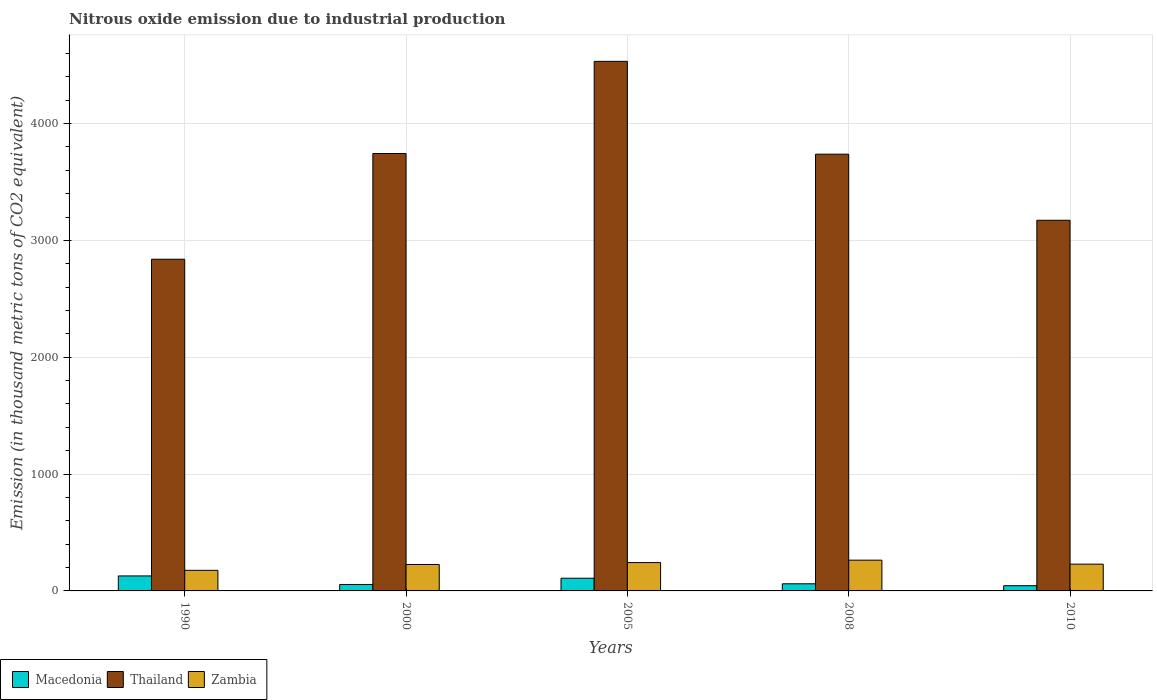How many different coloured bars are there?
Your response must be concise. 3. How many groups of bars are there?
Your answer should be very brief. 5. Are the number of bars per tick equal to the number of legend labels?
Your answer should be very brief. Yes. Are the number of bars on each tick of the X-axis equal?
Provide a succinct answer. Yes. How many bars are there on the 3rd tick from the left?
Ensure brevity in your answer.  3. What is the label of the 2nd group of bars from the left?
Provide a succinct answer. 2000. In how many cases, is the number of bars for a given year not equal to the number of legend labels?
Give a very brief answer. 0. What is the amount of nitrous oxide emitted in Macedonia in 1990?
Your answer should be very brief. 128.3. Across all years, what is the maximum amount of nitrous oxide emitted in Thailand?
Make the answer very short. 4532.4. Across all years, what is the minimum amount of nitrous oxide emitted in Zambia?
Your response must be concise. 176.2. In which year was the amount of nitrous oxide emitted in Thailand minimum?
Offer a terse response. 1990. What is the total amount of nitrous oxide emitted in Zambia in the graph?
Keep it short and to the point. 1137.6. What is the difference between the amount of nitrous oxide emitted in Zambia in 2005 and the amount of nitrous oxide emitted in Thailand in 1990?
Your answer should be very brief. -2596.2. What is the average amount of nitrous oxide emitted in Macedonia per year?
Offer a very short reply. 79.54. In the year 2010, what is the difference between the amount of nitrous oxide emitted in Zambia and amount of nitrous oxide emitted in Thailand?
Keep it short and to the point. -2943.2. What is the ratio of the amount of nitrous oxide emitted in Zambia in 2000 to that in 2005?
Provide a succinct answer. 0.93. Is the difference between the amount of nitrous oxide emitted in Zambia in 1990 and 2005 greater than the difference between the amount of nitrous oxide emitted in Thailand in 1990 and 2005?
Offer a very short reply. Yes. What is the difference between the highest and the second highest amount of nitrous oxide emitted in Thailand?
Your answer should be very brief. 788.7. What is the difference between the highest and the lowest amount of nitrous oxide emitted in Zambia?
Provide a succinct answer. 87.1. What does the 2nd bar from the left in 2005 represents?
Keep it short and to the point. Thailand. What does the 1st bar from the right in 2008 represents?
Keep it short and to the point. Zambia. Is it the case that in every year, the sum of the amount of nitrous oxide emitted in Thailand and amount of nitrous oxide emitted in Macedonia is greater than the amount of nitrous oxide emitted in Zambia?
Keep it short and to the point. Yes. How many bars are there?
Offer a very short reply. 15. Are all the bars in the graph horizontal?
Your answer should be very brief. No. How many years are there in the graph?
Make the answer very short. 5. What is the difference between two consecutive major ticks on the Y-axis?
Keep it short and to the point. 1000. Where does the legend appear in the graph?
Provide a succinct answer. Bottom left. How are the legend labels stacked?
Provide a succinct answer. Horizontal. What is the title of the graph?
Ensure brevity in your answer.  Nitrous oxide emission due to industrial production. What is the label or title of the X-axis?
Provide a succinct answer. Years. What is the label or title of the Y-axis?
Your response must be concise. Emission (in thousand metric tons of CO2 equivalent). What is the Emission (in thousand metric tons of CO2 equivalent) in Macedonia in 1990?
Your answer should be very brief. 128.3. What is the Emission (in thousand metric tons of CO2 equivalent) of Thailand in 1990?
Make the answer very short. 2838.9. What is the Emission (in thousand metric tons of CO2 equivalent) of Zambia in 1990?
Offer a very short reply. 176.2. What is the Emission (in thousand metric tons of CO2 equivalent) in Macedonia in 2000?
Make the answer very short. 55.2. What is the Emission (in thousand metric tons of CO2 equivalent) of Thailand in 2000?
Give a very brief answer. 3743.7. What is the Emission (in thousand metric tons of CO2 equivalent) of Zambia in 2000?
Give a very brief answer. 226.2. What is the Emission (in thousand metric tons of CO2 equivalent) of Macedonia in 2005?
Make the answer very short. 108.6. What is the Emission (in thousand metric tons of CO2 equivalent) of Thailand in 2005?
Make the answer very short. 4532.4. What is the Emission (in thousand metric tons of CO2 equivalent) in Zambia in 2005?
Your response must be concise. 242.7. What is the Emission (in thousand metric tons of CO2 equivalent) of Macedonia in 2008?
Provide a short and direct response. 61. What is the Emission (in thousand metric tons of CO2 equivalent) in Thailand in 2008?
Provide a succinct answer. 3737.9. What is the Emission (in thousand metric tons of CO2 equivalent) in Zambia in 2008?
Your response must be concise. 263.3. What is the Emission (in thousand metric tons of CO2 equivalent) of Macedonia in 2010?
Give a very brief answer. 44.6. What is the Emission (in thousand metric tons of CO2 equivalent) in Thailand in 2010?
Your answer should be very brief. 3172.4. What is the Emission (in thousand metric tons of CO2 equivalent) of Zambia in 2010?
Make the answer very short. 229.2. Across all years, what is the maximum Emission (in thousand metric tons of CO2 equivalent) of Macedonia?
Your answer should be very brief. 128.3. Across all years, what is the maximum Emission (in thousand metric tons of CO2 equivalent) of Thailand?
Provide a succinct answer. 4532.4. Across all years, what is the maximum Emission (in thousand metric tons of CO2 equivalent) in Zambia?
Provide a short and direct response. 263.3. Across all years, what is the minimum Emission (in thousand metric tons of CO2 equivalent) in Macedonia?
Ensure brevity in your answer.  44.6. Across all years, what is the minimum Emission (in thousand metric tons of CO2 equivalent) of Thailand?
Give a very brief answer. 2838.9. Across all years, what is the minimum Emission (in thousand metric tons of CO2 equivalent) in Zambia?
Your answer should be very brief. 176.2. What is the total Emission (in thousand metric tons of CO2 equivalent) in Macedonia in the graph?
Offer a very short reply. 397.7. What is the total Emission (in thousand metric tons of CO2 equivalent) of Thailand in the graph?
Offer a terse response. 1.80e+04. What is the total Emission (in thousand metric tons of CO2 equivalent) in Zambia in the graph?
Provide a short and direct response. 1137.6. What is the difference between the Emission (in thousand metric tons of CO2 equivalent) of Macedonia in 1990 and that in 2000?
Give a very brief answer. 73.1. What is the difference between the Emission (in thousand metric tons of CO2 equivalent) in Thailand in 1990 and that in 2000?
Ensure brevity in your answer.  -904.8. What is the difference between the Emission (in thousand metric tons of CO2 equivalent) in Macedonia in 1990 and that in 2005?
Provide a succinct answer. 19.7. What is the difference between the Emission (in thousand metric tons of CO2 equivalent) of Thailand in 1990 and that in 2005?
Give a very brief answer. -1693.5. What is the difference between the Emission (in thousand metric tons of CO2 equivalent) in Zambia in 1990 and that in 2005?
Give a very brief answer. -66.5. What is the difference between the Emission (in thousand metric tons of CO2 equivalent) in Macedonia in 1990 and that in 2008?
Your response must be concise. 67.3. What is the difference between the Emission (in thousand metric tons of CO2 equivalent) of Thailand in 1990 and that in 2008?
Provide a succinct answer. -899. What is the difference between the Emission (in thousand metric tons of CO2 equivalent) in Zambia in 1990 and that in 2008?
Provide a short and direct response. -87.1. What is the difference between the Emission (in thousand metric tons of CO2 equivalent) in Macedonia in 1990 and that in 2010?
Give a very brief answer. 83.7. What is the difference between the Emission (in thousand metric tons of CO2 equivalent) in Thailand in 1990 and that in 2010?
Provide a succinct answer. -333.5. What is the difference between the Emission (in thousand metric tons of CO2 equivalent) in Zambia in 1990 and that in 2010?
Your answer should be very brief. -53. What is the difference between the Emission (in thousand metric tons of CO2 equivalent) in Macedonia in 2000 and that in 2005?
Your answer should be very brief. -53.4. What is the difference between the Emission (in thousand metric tons of CO2 equivalent) in Thailand in 2000 and that in 2005?
Offer a very short reply. -788.7. What is the difference between the Emission (in thousand metric tons of CO2 equivalent) in Zambia in 2000 and that in 2005?
Your answer should be very brief. -16.5. What is the difference between the Emission (in thousand metric tons of CO2 equivalent) in Macedonia in 2000 and that in 2008?
Give a very brief answer. -5.8. What is the difference between the Emission (in thousand metric tons of CO2 equivalent) of Zambia in 2000 and that in 2008?
Your answer should be compact. -37.1. What is the difference between the Emission (in thousand metric tons of CO2 equivalent) of Macedonia in 2000 and that in 2010?
Make the answer very short. 10.6. What is the difference between the Emission (in thousand metric tons of CO2 equivalent) in Thailand in 2000 and that in 2010?
Provide a short and direct response. 571.3. What is the difference between the Emission (in thousand metric tons of CO2 equivalent) in Zambia in 2000 and that in 2010?
Offer a very short reply. -3. What is the difference between the Emission (in thousand metric tons of CO2 equivalent) of Macedonia in 2005 and that in 2008?
Give a very brief answer. 47.6. What is the difference between the Emission (in thousand metric tons of CO2 equivalent) in Thailand in 2005 and that in 2008?
Give a very brief answer. 794.5. What is the difference between the Emission (in thousand metric tons of CO2 equivalent) of Zambia in 2005 and that in 2008?
Your response must be concise. -20.6. What is the difference between the Emission (in thousand metric tons of CO2 equivalent) in Macedonia in 2005 and that in 2010?
Offer a very short reply. 64. What is the difference between the Emission (in thousand metric tons of CO2 equivalent) in Thailand in 2005 and that in 2010?
Provide a succinct answer. 1360. What is the difference between the Emission (in thousand metric tons of CO2 equivalent) in Zambia in 2005 and that in 2010?
Offer a terse response. 13.5. What is the difference between the Emission (in thousand metric tons of CO2 equivalent) of Thailand in 2008 and that in 2010?
Give a very brief answer. 565.5. What is the difference between the Emission (in thousand metric tons of CO2 equivalent) in Zambia in 2008 and that in 2010?
Give a very brief answer. 34.1. What is the difference between the Emission (in thousand metric tons of CO2 equivalent) of Macedonia in 1990 and the Emission (in thousand metric tons of CO2 equivalent) of Thailand in 2000?
Provide a short and direct response. -3615.4. What is the difference between the Emission (in thousand metric tons of CO2 equivalent) of Macedonia in 1990 and the Emission (in thousand metric tons of CO2 equivalent) of Zambia in 2000?
Keep it short and to the point. -97.9. What is the difference between the Emission (in thousand metric tons of CO2 equivalent) in Thailand in 1990 and the Emission (in thousand metric tons of CO2 equivalent) in Zambia in 2000?
Your answer should be compact. 2612.7. What is the difference between the Emission (in thousand metric tons of CO2 equivalent) of Macedonia in 1990 and the Emission (in thousand metric tons of CO2 equivalent) of Thailand in 2005?
Provide a short and direct response. -4404.1. What is the difference between the Emission (in thousand metric tons of CO2 equivalent) in Macedonia in 1990 and the Emission (in thousand metric tons of CO2 equivalent) in Zambia in 2005?
Ensure brevity in your answer.  -114.4. What is the difference between the Emission (in thousand metric tons of CO2 equivalent) in Thailand in 1990 and the Emission (in thousand metric tons of CO2 equivalent) in Zambia in 2005?
Your answer should be compact. 2596.2. What is the difference between the Emission (in thousand metric tons of CO2 equivalent) in Macedonia in 1990 and the Emission (in thousand metric tons of CO2 equivalent) in Thailand in 2008?
Offer a terse response. -3609.6. What is the difference between the Emission (in thousand metric tons of CO2 equivalent) of Macedonia in 1990 and the Emission (in thousand metric tons of CO2 equivalent) of Zambia in 2008?
Your response must be concise. -135. What is the difference between the Emission (in thousand metric tons of CO2 equivalent) in Thailand in 1990 and the Emission (in thousand metric tons of CO2 equivalent) in Zambia in 2008?
Your answer should be very brief. 2575.6. What is the difference between the Emission (in thousand metric tons of CO2 equivalent) in Macedonia in 1990 and the Emission (in thousand metric tons of CO2 equivalent) in Thailand in 2010?
Give a very brief answer. -3044.1. What is the difference between the Emission (in thousand metric tons of CO2 equivalent) in Macedonia in 1990 and the Emission (in thousand metric tons of CO2 equivalent) in Zambia in 2010?
Your response must be concise. -100.9. What is the difference between the Emission (in thousand metric tons of CO2 equivalent) in Thailand in 1990 and the Emission (in thousand metric tons of CO2 equivalent) in Zambia in 2010?
Keep it short and to the point. 2609.7. What is the difference between the Emission (in thousand metric tons of CO2 equivalent) of Macedonia in 2000 and the Emission (in thousand metric tons of CO2 equivalent) of Thailand in 2005?
Make the answer very short. -4477.2. What is the difference between the Emission (in thousand metric tons of CO2 equivalent) in Macedonia in 2000 and the Emission (in thousand metric tons of CO2 equivalent) in Zambia in 2005?
Your answer should be very brief. -187.5. What is the difference between the Emission (in thousand metric tons of CO2 equivalent) of Thailand in 2000 and the Emission (in thousand metric tons of CO2 equivalent) of Zambia in 2005?
Your answer should be very brief. 3501. What is the difference between the Emission (in thousand metric tons of CO2 equivalent) of Macedonia in 2000 and the Emission (in thousand metric tons of CO2 equivalent) of Thailand in 2008?
Make the answer very short. -3682.7. What is the difference between the Emission (in thousand metric tons of CO2 equivalent) of Macedonia in 2000 and the Emission (in thousand metric tons of CO2 equivalent) of Zambia in 2008?
Provide a short and direct response. -208.1. What is the difference between the Emission (in thousand metric tons of CO2 equivalent) of Thailand in 2000 and the Emission (in thousand metric tons of CO2 equivalent) of Zambia in 2008?
Give a very brief answer. 3480.4. What is the difference between the Emission (in thousand metric tons of CO2 equivalent) in Macedonia in 2000 and the Emission (in thousand metric tons of CO2 equivalent) in Thailand in 2010?
Ensure brevity in your answer.  -3117.2. What is the difference between the Emission (in thousand metric tons of CO2 equivalent) of Macedonia in 2000 and the Emission (in thousand metric tons of CO2 equivalent) of Zambia in 2010?
Provide a short and direct response. -174. What is the difference between the Emission (in thousand metric tons of CO2 equivalent) of Thailand in 2000 and the Emission (in thousand metric tons of CO2 equivalent) of Zambia in 2010?
Your answer should be very brief. 3514.5. What is the difference between the Emission (in thousand metric tons of CO2 equivalent) of Macedonia in 2005 and the Emission (in thousand metric tons of CO2 equivalent) of Thailand in 2008?
Ensure brevity in your answer.  -3629.3. What is the difference between the Emission (in thousand metric tons of CO2 equivalent) in Macedonia in 2005 and the Emission (in thousand metric tons of CO2 equivalent) in Zambia in 2008?
Keep it short and to the point. -154.7. What is the difference between the Emission (in thousand metric tons of CO2 equivalent) in Thailand in 2005 and the Emission (in thousand metric tons of CO2 equivalent) in Zambia in 2008?
Provide a short and direct response. 4269.1. What is the difference between the Emission (in thousand metric tons of CO2 equivalent) of Macedonia in 2005 and the Emission (in thousand metric tons of CO2 equivalent) of Thailand in 2010?
Offer a terse response. -3063.8. What is the difference between the Emission (in thousand metric tons of CO2 equivalent) in Macedonia in 2005 and the Emission (in thousand metric tons of CO2 equivalent) in Zambia in 2010?
Offer a terse response. -120.6. What is the difference between the Emission (in thousand metric tons of CO2 equivalent) in Thailand in 2005 and the Emission (in thousand metric tons of CO2 equivalent) in Zambia in 2010?
Provide a succinct answer. 4303.2. What is the difference between the Emission (in thousand metric tons of CO2 equivalent) of Macedonia in 2008 and the Emission (in thousand metric tons of CO2 equivalent) of Thailand in 2010?
Give a very brief answer. -3111.4. What is the difference between the Emission (in thousand metric tons of CO2 equivalent) in Macedonia in 2008 and the Emission (in thousand metric tons of CO2 equivalent) in Zambia in 2010?
Offer a very short reply. -168.2. What is the difference between the Emission (in thousand metric tons of CO2 equivalent) in Thailand in 2008 and the Emission (in thousand metric tons of CO2 equivalent) in Zambia in 2010?
Provide a succinct answer. 3508.7. What is the average Emission (in thousand metric tons of CO2 equivalent) in Macedonia per year?
Your answer should be very brief. 79.54. What is the average Emission (in thousand metric tons of CO2 equivalent) in Thailand per year?
Offer a terse response. 3605.06. What is the average Emission (in thousand metric tons of CO2 equivalent) in Zambia per year?
Offer a terse response. 227.52. In the year 1990, what is the difference between the Emission (in thousand metric tons of CO2 equivalent) in Macedonia and Emission (in thousand metric tons of CO2 equivalent) in Thailand?
Ensure brevity in your answer.  -2710.6. In the year 1990, what is the difference between the Emission (in thousand metric tons of CO2 equivalent) of Macedonia and Emission (in thousand metric tons of CO2 equivalent) of Zambia?
Your answer should be very brief. -47.9. In the year 1990, what is the difference between the Emission (in thousand metric tons of CO2 equivalent) in Thailand and Emission (in thousand metric tons of CO2 equivalent) in Zambia?
Your response must be concise. 2662.7. In the year 2000, what is the difference between the Emission (in thousand metric tons of CO2 equivalent) of Macedonia and Emission (in thousand metric tons of CO2 equivalent) of Thailand?
Your answer should be compact. -3688.5. In the year 2000, what is the difference between the Emission (in thousand metric tons of CO2 equivalent) of Macedonia and Emission (in thousand metric tons of CO2 equivalent) of Zambia?
Make the answer very short. -171. In the year 2000, what is the difference between the Emission (in thousand metric tons of CO2 equivalent) of Thailand and Emission (in thousand metric tons of CO2 equivalent) of Zambia?
Make the answer very short. 3517.5. In the year 2005, what is the difference between the Emission (in thousand metric tons of CO2 equivalent) of Macedonia and Emission (in thousand metric tons of CO2 equivalent) of Thailand?
Your answer should be compact. -4423.8. In the year 2005, what is the difference between the Emission (in thousand metric tons of CO2 equivalent) in Macedonia and Emission (in thousand metric tons of CO2 equivalent) in Zambia?
Provide a succinct answer. -134.1. In the year 2005, what is the difference between the Emission (in thousand metric tons of CO2 equivalent) of Thailand and Emission (in thousand metric tons of CO2 equivalent) of Zambia?
Offer a very short reply. 4289.7. In the year 2008, what is the difference between the Emission (in thousand metric tons of CO2 equivalent) in Macedonia and Emission (in thousand metric tons of CO2 equivalent) in Thailand?
Provide a short and direct response. -3676.9. In the year 2008, what is the difference between the Emission (in thousand metric tons of CO2 equivalent) of Macedonia and Emission (in thousand metric tons of CO2 equivalent) of Zambia?
Keep it short and to the point. -202.3. In the year 2008, what is the difference between the Emission (in thousand metric tons of CO2 equivalent) of Thailand and Emission (in thousand metric tons of CO2 equivalent) of Zambia?
Your answer should be compact. 3474.6. In the year 2010, what is the difference between the Emission (in thousand metric tons of CO2 equivalent) in Macedonia and Emission (in thousand metric tons of CO2 equivalent) in Thailand?
Make the answer very short. -3127.8. In the year 2010, what is the difference between the Emission (in thousand metric tons of CO2 equivalent) of Macedonia and Emission (in thousand metric tons of CO2 equivalent) of Zambia?
Keep it short and to the point. -184.6. In the year 2010, what is the difference between the Emission (in thousand metric tons of CO2 equivalent) of Thailand and Emission (in thousand metric tons of CO2 equivalent) of Zambia?
Offer a terse response. 2943.2. What is the ratio of the Emission (in thousand metric tons of CO2 equivalent) of Macedonia in 1990 to that in 2000?
Keep it short and to the point. 2.32. What is the ratio of the Emission (in thousand metric tons of CO2 equivalent) of Thailand in 1990 to that in 2000?
Your response must be concise. 0.76. What is the ratio of the Emission (in thousand metric tons of CO2 equivalent) of Zambia in 1990 to that in 2000?
Provide a short and direct response. 0.78. What is the ratio of the Emission (in thousand metric tons of CO2 equivalent) in Macedonia in 1990 to that in 2005?
Make the answer very short. 1.18. What is the ratio of the Emission (in thousand metric tons of CO2 equivalent) of Thailand in 1990 to that in 2005?
Keep it short and to the point. 0.63. What is the ratio of the Emission (in thousand metric tons of CO2 equivalent) of Zambia in 1990 to that in 2005?
Provide a succinct answer. 0.73. What is the ratio of the Emission (in thousand metric tons of CO2 equivalent) in Macedonia in 1990 to that in 2008?
Your answer should be very brief. 2.1. What is the ratio of the Emission (in thousand metric tons of CO2 equivalent) in Thailand in 1990 to that in 2008?
Offer a very short reply. 0.76. What is the ratio of the Emission (in thousand metric tons of CO2 equivalent) of Zambia in 1990 to that in 2008?
Ensure brevity in your answer.  0.67. What is the ratio of the Emission (in thousand metric tons of CO2 equivalent) in Macedonia in 1990 to that in 2010?
Your answer should be compact. 2.88. What is the ratio of the Emission (in thousand metric tons of CO2 equivalent) of Thailand in 1990 to that in 2010?
Your answer should be compact. 0.89. What is the ratio of the Emission (in thousand metric tons of CO2 equivalent) of Zambia in 1990 to that in 2010?
Ensure brevity in your answer.  0.77. What is the ratio of the Emission (in thousand metric tons of CO2 equivalent) in Macedonia in 2000 to that in 2005?
Your response must be concise. 0.51. What is the ratio of the Emission (in thousand metric tons of CO2 equivalent) in Thailand in 2000 to that in 2005?
Your answer should be very brief. 0.83. What is the ratio of the Emission (in thousand metric tons of CO2 equivalent) of Zambia in 2000 to that in 2005?
Offer a terse response. 0.93. What is the ratio of the Emission (in thousand metric tons of CO2 equivalent) in Macedonia in 2000 to that in 2008?
Give a very brief answer. 0.9. What is the ratio of the Emission (in thousand metric tons of CO2 equivalent) in Zambia in 2000 to that in 2008?
Your answer should be very brief. 0.86. What is the ratio of the Emission (in thousand metric tons of CO2 equivalent) of Macedonia in 2000 to that in 2010?
Keep it short and to the point. 1.24. What is the ratio of the Emission (in thousand metric tons of CO2 equivalent) in Thailand in 2000 to that in 2010?
Provide a succinct answer. 1.18. What is the ratio of the Emission (in thousand metric tons of CO2 equivalent) of Zambia in 2000 to that in 2010?
Ensure brevity in your answer.  0.99. What is the ratio of the Emission (in thousand metric tons of CO2 equivalent) in Macedonia in 2005 to that in 2008?
Make the answer very short. 1.78. What is the ratio of the Emission (in thousand metric tons of CO2 equivalent) of Thailand in 2005 to that in 2008?
Provide a succinct answer. 1.21. What is the ratio of the Emission (in thousand metric tons of CO2 equivalent) in Zambia in 2005 to that in 2008?
Your answer should be very brief. 0.92. What is the ratio of the Emission (in thousand metric tons of CO2 equivalent) of Macedonia in 2005 to that in 2010?
Make the answer very short. 2.44. What is the ratio of the Emission (in thousand metric tons of CO2 equivalent) of Thailand in 2005 to that in 2010?
Provide a short and direct response. 1.43. What is the ratio of the Emission (in thousand metric tons of CO2 equivalent) of Zambia in 2005 to that in 2010?
Provide a short and direct response. 1.06. What is the ratio of the Emission (in thousand metric tons of CO2 equivalent) of Macedonia in 2008 to that in 2010?
Give a very brief answer. 1.37. What is the ratio of the Emission (in thousand metric tons of CO2 equivalent) in Thailand in 2008 to that in 2010?
Ensure brevity in your answer.  1.18. What is the ratio of the Emission (in thousand metric tons of CO2 equivalent) of Zambia in 2008 to that in 2010?
Provide a short and direct response. 1.15. What is the difference between the highest and the second highest Emission (in thousand metric tons of CO2 equivalent) in Macedonia?
Keep it short and to the point. 19.7. What is the difference between the highest and the second highest Emission (in thousand metric tons of CO2 equivalent) of Thailand?
Your response must be concise. 788.7. What is the difference between the highest and the second highest Emission (in thousand metric tons of CO2 equivalent) of Zambia?
Provide a succinct answer. 20.6. What is the difference between the highest and the lowest Emission (in thousand metric tons of CO2 equivalent) of Macedonia?
Offer a very short reply. 83.7. What is the difference between the highest and the lowest Emission (in thousand metric tons of CO2 equivalent) of Thailand?
Your answer should be compact. 1693.5. What is the difference between the highest and the lowest Emission (in thousand metric tons of CO2 equivalent) of Zambia?
Give a very brief answer. 87.1. 